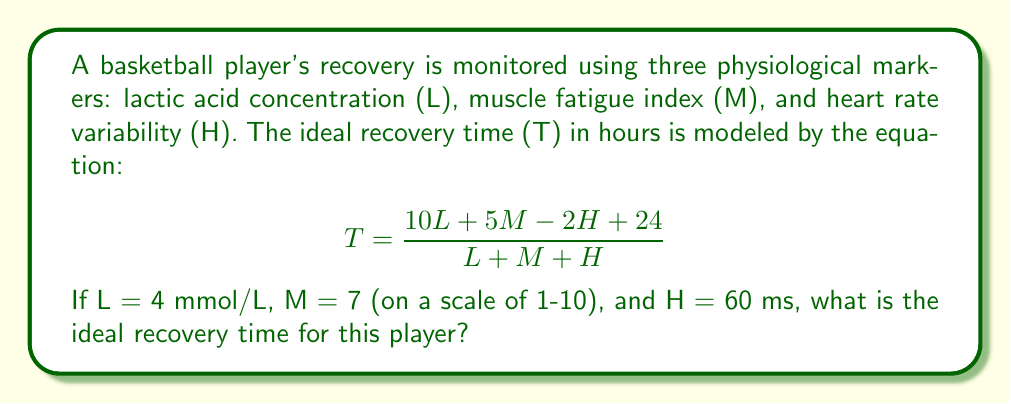Could you help me with this problem? To solve this problem, we'll follow these steps:

1. Identify the given values:
   L = 4 mmol/L
   M = 7
   H = 60 ms

2. Substitute these values into the equation:

   $$T = \frac{10L + 5M - 2H + 24}{L + M + H}$$

3. Calculate the numerator:
   10L = 10 * 4 = 40
   5M = 5 * 7 = 35
   -2H = -2 * 60 = -120
   
   Numerator = 40 + 35 - 120 + 24 = -21

4. Calculate the denominator:
   L + M + H = 4 + 7 + 60 = 71

5. Divide the numerator by the denominator:

   $$T = \frac{-21}{71} \approx -0.2958$$

6. Since time cannot be negative, we interpret this result as 0 hours of recovery time needed.

This result suggests that the player has already fully recovered based on the given physiological markers.
Answer: 0 hours 